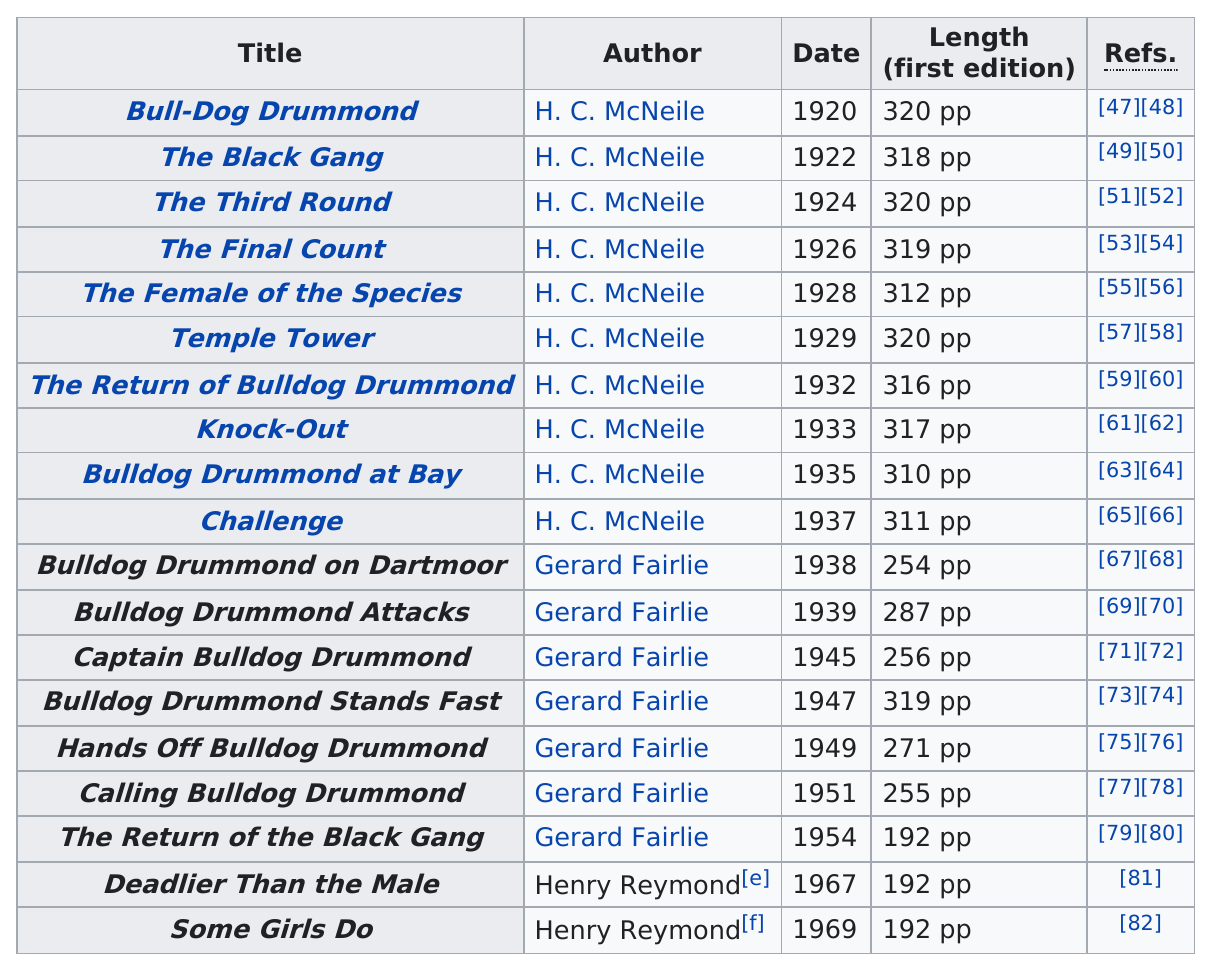Outline some significant characteristics in this image. The book with the title "Bull-Dog Drummond" was published before 1921. In 1920, the earliest edition of the Bull-Dog Drummond series was published. The number of titles from the 1940's was 3. After Harry Colmworth McNeille, who succeeded him in writing books about Bulldog Drummond, Gerard Fairlie wrote books about Bulldog Drummond. Henry Rymond wrote 2 titles. 